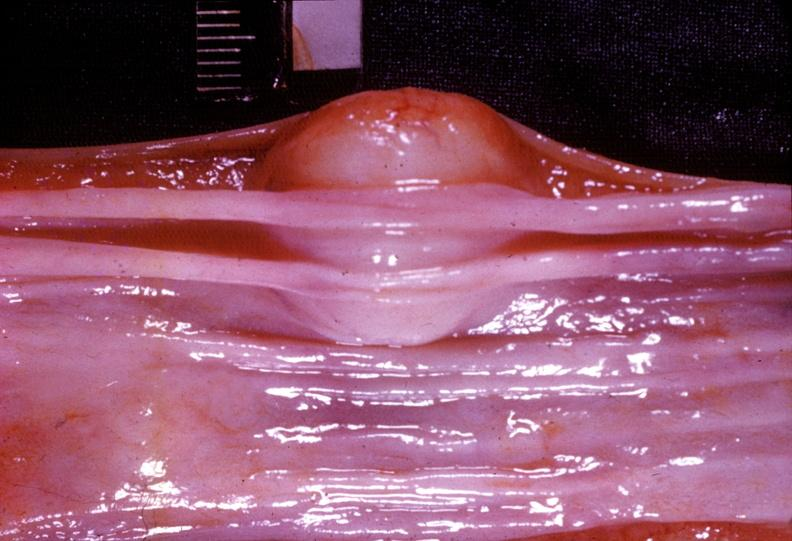what does this image show?
Answer the question using a single word or phrase. Esophagus 